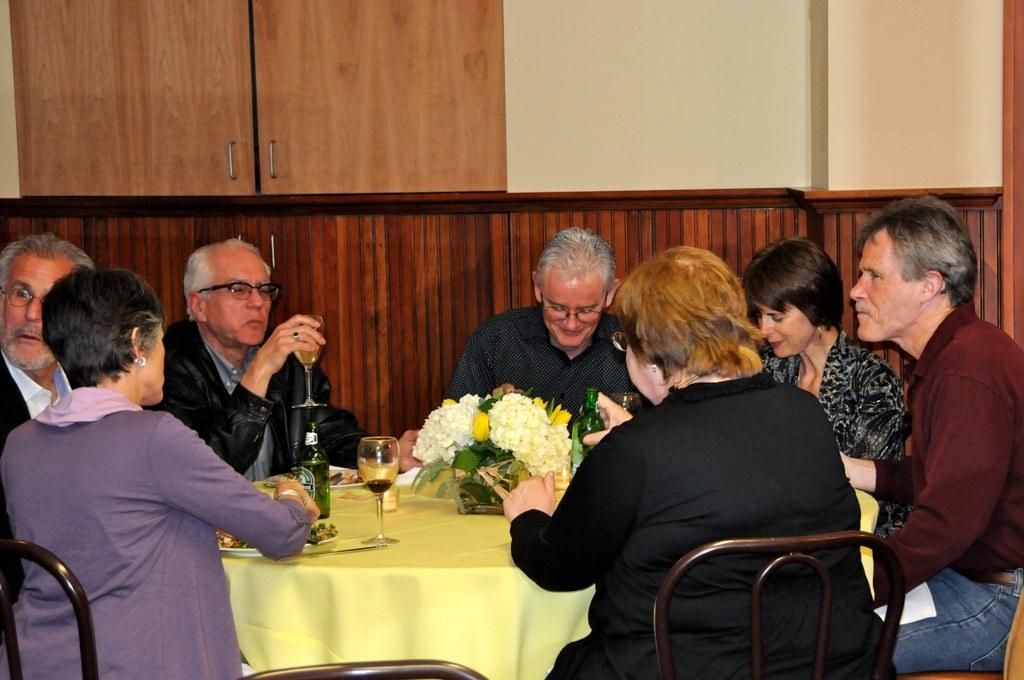What are the people in the image doing? The people in the image are sitting on chairs around a table. What can be seen on the table? There are wine bottles, glasses, and plates on the table. What is visible in the background of the image? There is a wall and cupboards in the background. What type of mark can be seen on the jelly in the image? There is no jelly present in the image, so it is not possible to determine if there is a mark on it. 